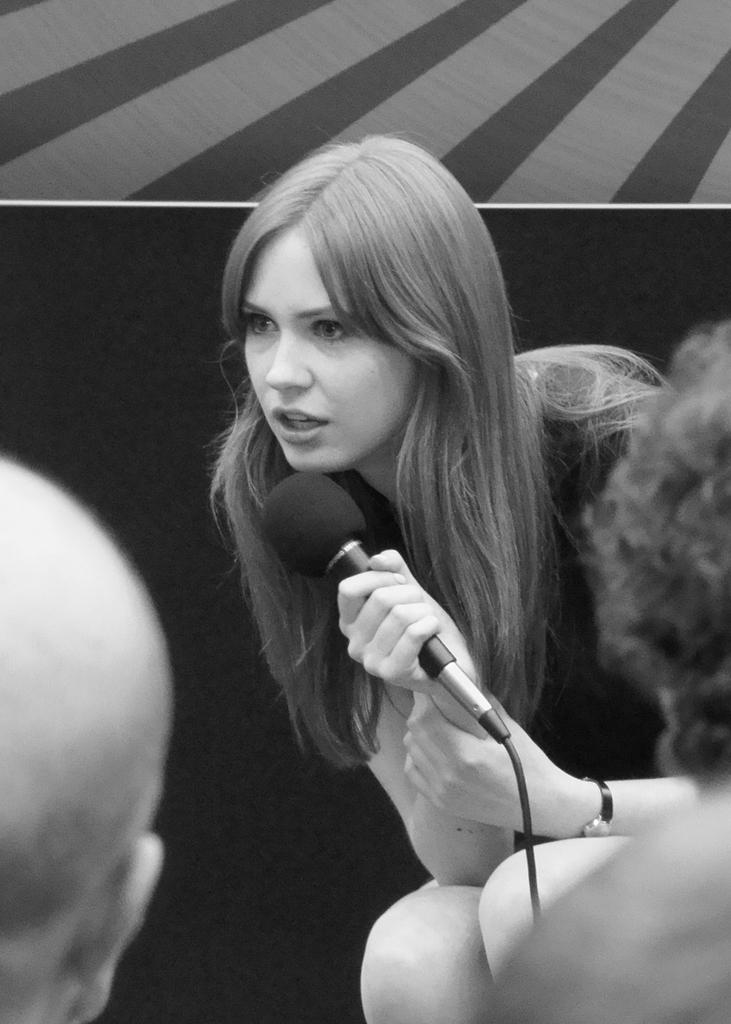Who is the main subject in the image? There is a woman in the image. What is the woman holding in the image? The woman is holding a microphone. How many people's heads can be seen in the image? There are two people's heads visible in the image. What type of boat is being traded between the two people in the image? There is no boat or trade present in the image; it features a woman holding a microphone and two people's heads visible. Can you tell me how many cows are in the image? There are no cows present in the image. 